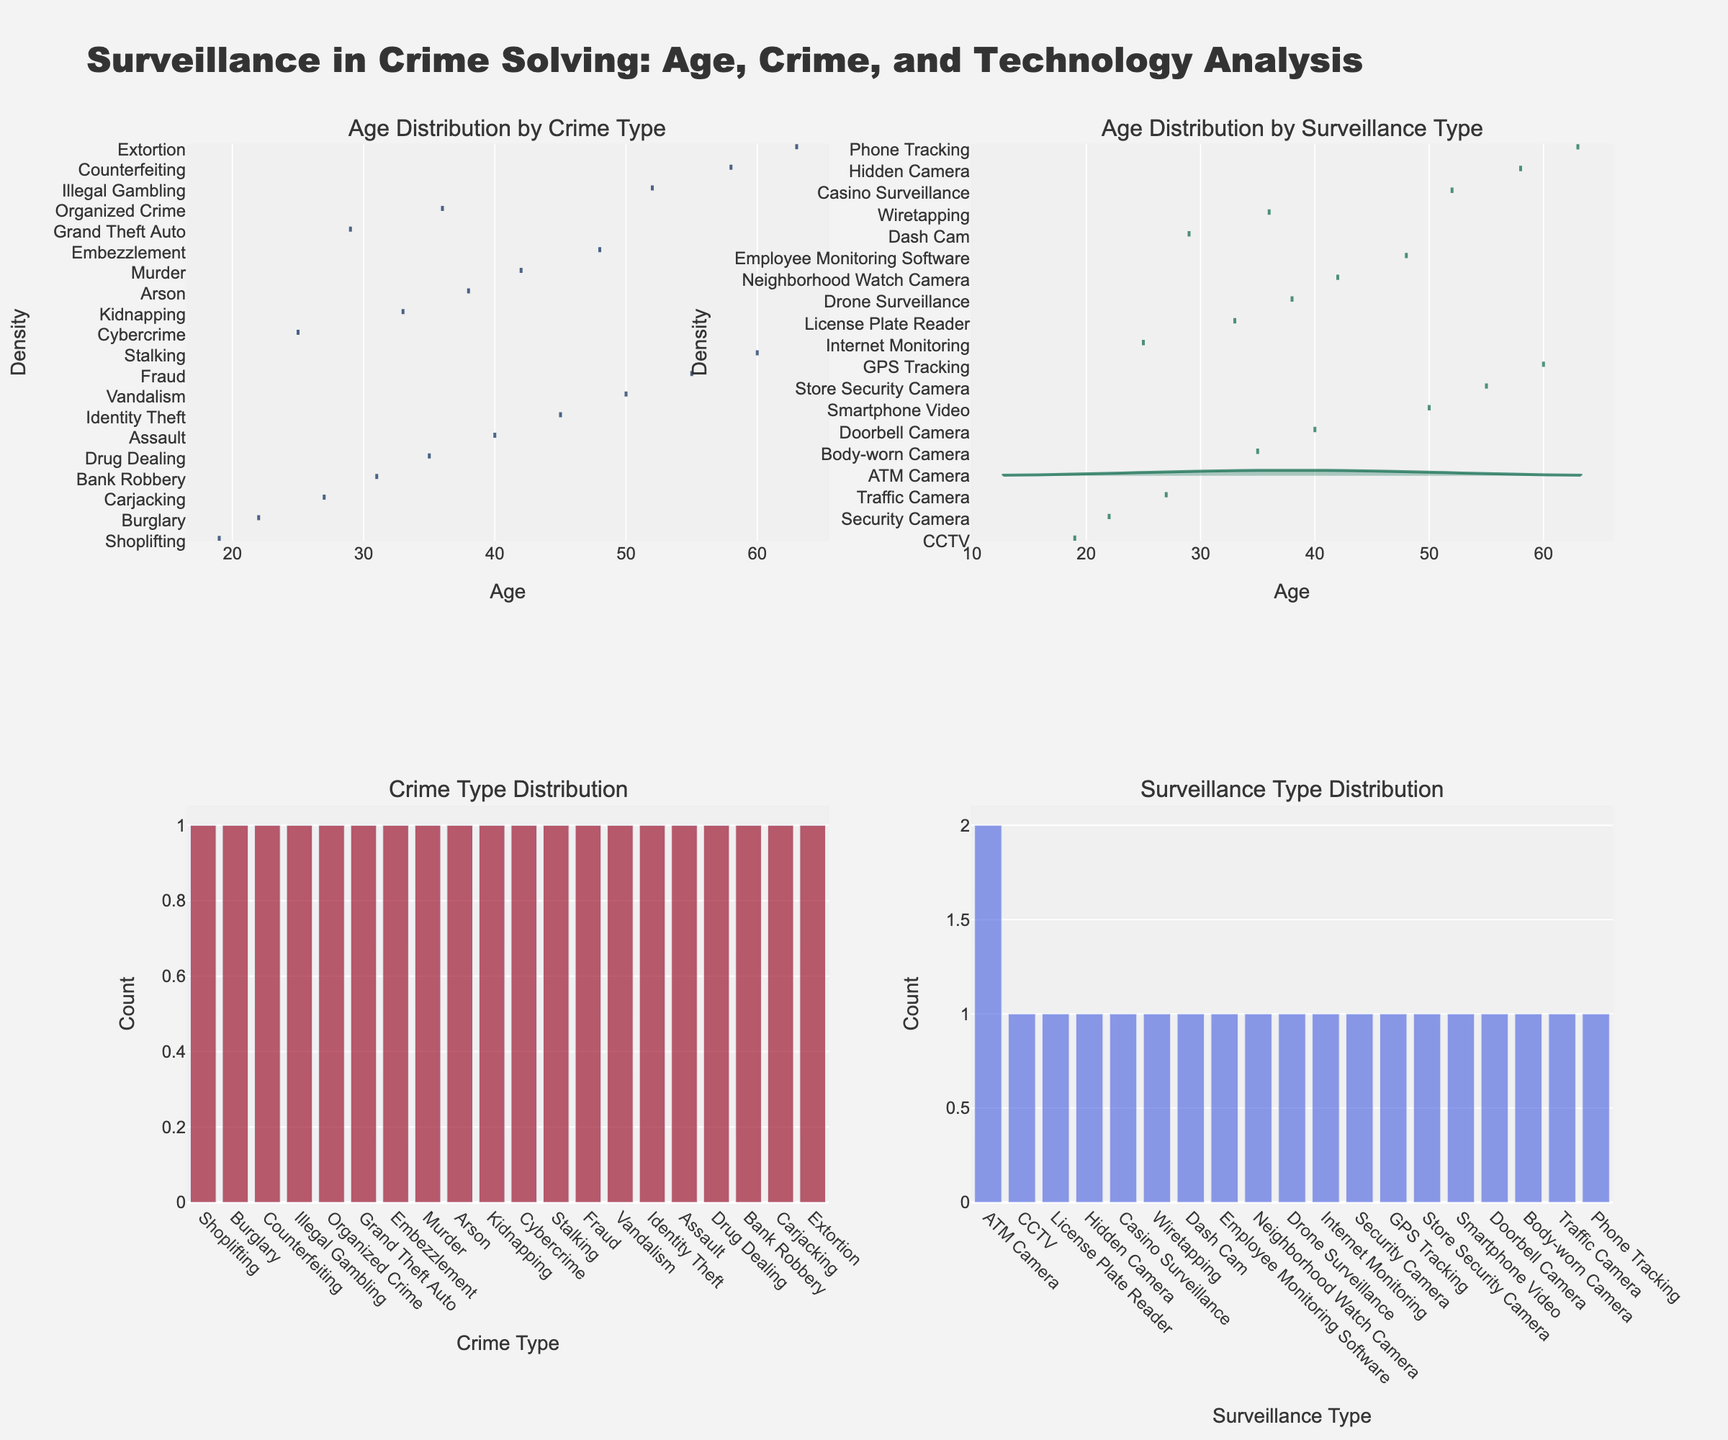What's the title of the figure? The title is usually placed at the top of the figure. The title in this case is "Surveillance in Crime Solving: Age, Crime, and Technology Analysis".
Answer: Surveillance in Crime Solving: Age, Crime, and Technology Analysis What's the Age Distribution for the crime "Carjacking"? Check the Age Distribution by Crime Type subplot in the first row. Look for the "Carjacking" data, which uses a violin plot. The age for "Carjacking" shows a density centered around 27 years old.
Answer: 27 years Which crime type has the highest count? In the Crime Type Distribution subplot in the second row, the heights of the bars represent the counts. Identify the tallest bar. Since the distribution is relatively even, identify the one with the most significant height among them.
Answer: Shoplifting Which surveillance type is associated with the highest age? Refer to the Age Distribution by Surveillance Type subplot. The types of surveillance with older age values can be checked, focusing on the GPS Tracking density plot showing a peak at 60 years.
Answer: GPS Tracking Which surveillance type is the most common? Look at the Surveillance Type Distribution subplot. The surveillance type with the tallest bar is the most common, implying that “ATM Camera” and "Store Security Camera" appear more frequently, but should be confirmed by bar height.
Answer: ATM Camera What's the overall age range captured in this dataset for all types of crimes? Observe the x-axes of the age distribution plots. The ages range from the lowest visible age point to the highest. Here, it ranges from 19 to 63 years.
Answer: 19 to 63 years How do age distributions differ between CCTV and Drone Surveillance? Compare the violin plots for both types under the "Age Distribution by Surveillance Type" subplot. CCTV shows a density around younger ages like 19, while Drone Surveillance is centered around older ages like 38.
Answer: Younger for CCTV, Older for Drone Surveillance 